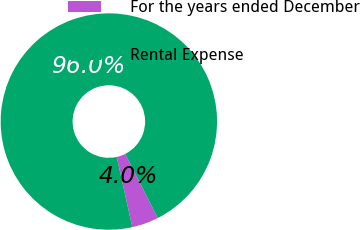<chart> <loc_0><loc_0><loc_500><loc_500><pie_chart><fcel>For the years ended December<fcel>Rental Expense<nl><fcel>3.98%<fcel>96.02%<nl></chart> 